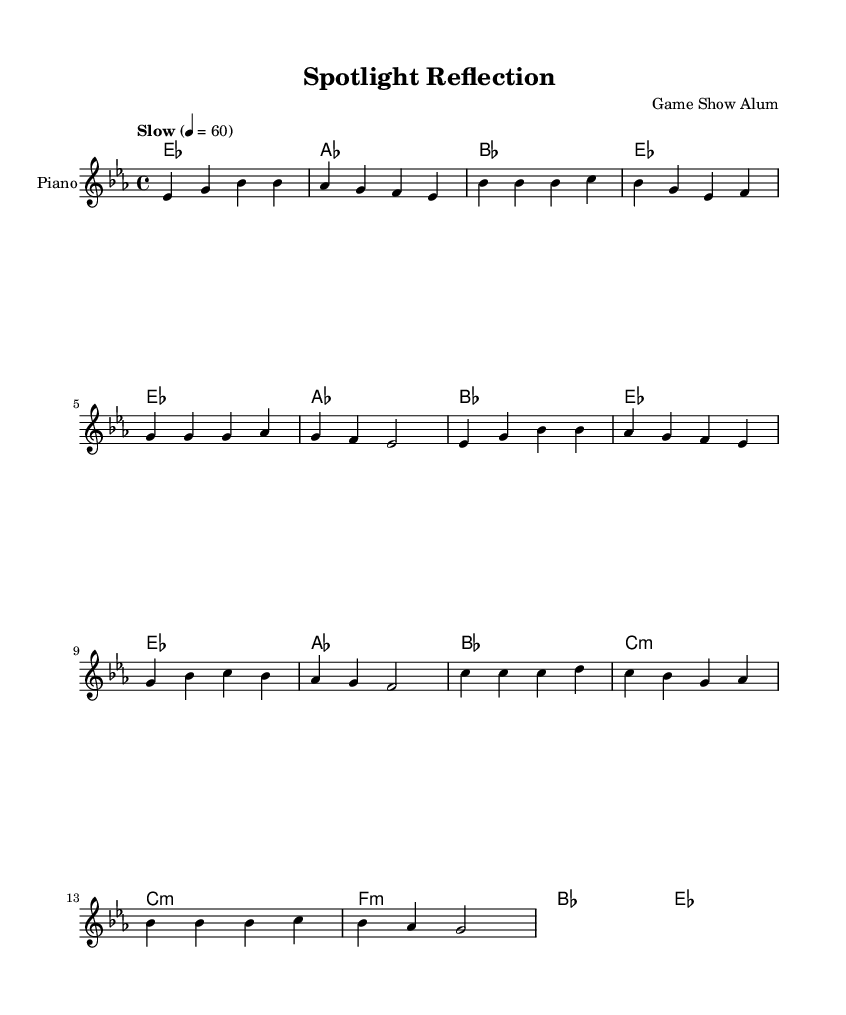What is the key signature of this music? The key signature is E-flat major, indicated by the presence of three flat symbols (B-flat, E-flat, and A-flat) in the sheet music.
Answer: E-flat major What is the time signature? The time signature is 4/4, which means there are four beats in each measure and the quarter note gets one beat. This is shown at the beginning of the sheet music.
Answer: 4/4 What is the tempo marking for this piece? The tempo marking is "Slow" with a metronome marking of 60 beats per minute, indicating a leisurely pace. This information is found at the beginning of the score.
Answer: Slow 4 = 60 How many measures are there in the verse section? The verse section consists of four measures, identifiable by the sequence where the melody and harmonies are repeated. Counting these measures confirms the total.
Answer: 4 measures What is the final chord in the bridge? The final chord in the bridge is E-flat major, as indicated by the chord notation provided for that section of the score. This is confirmed by the last line of the harmonies.
Answer: E-flat major Which section has a different time signature? None of the sections have a different time signature; all sections maintain the 4/4 time signature throughout the entire piece. This is consistently noted across all sections.
Answer: None 